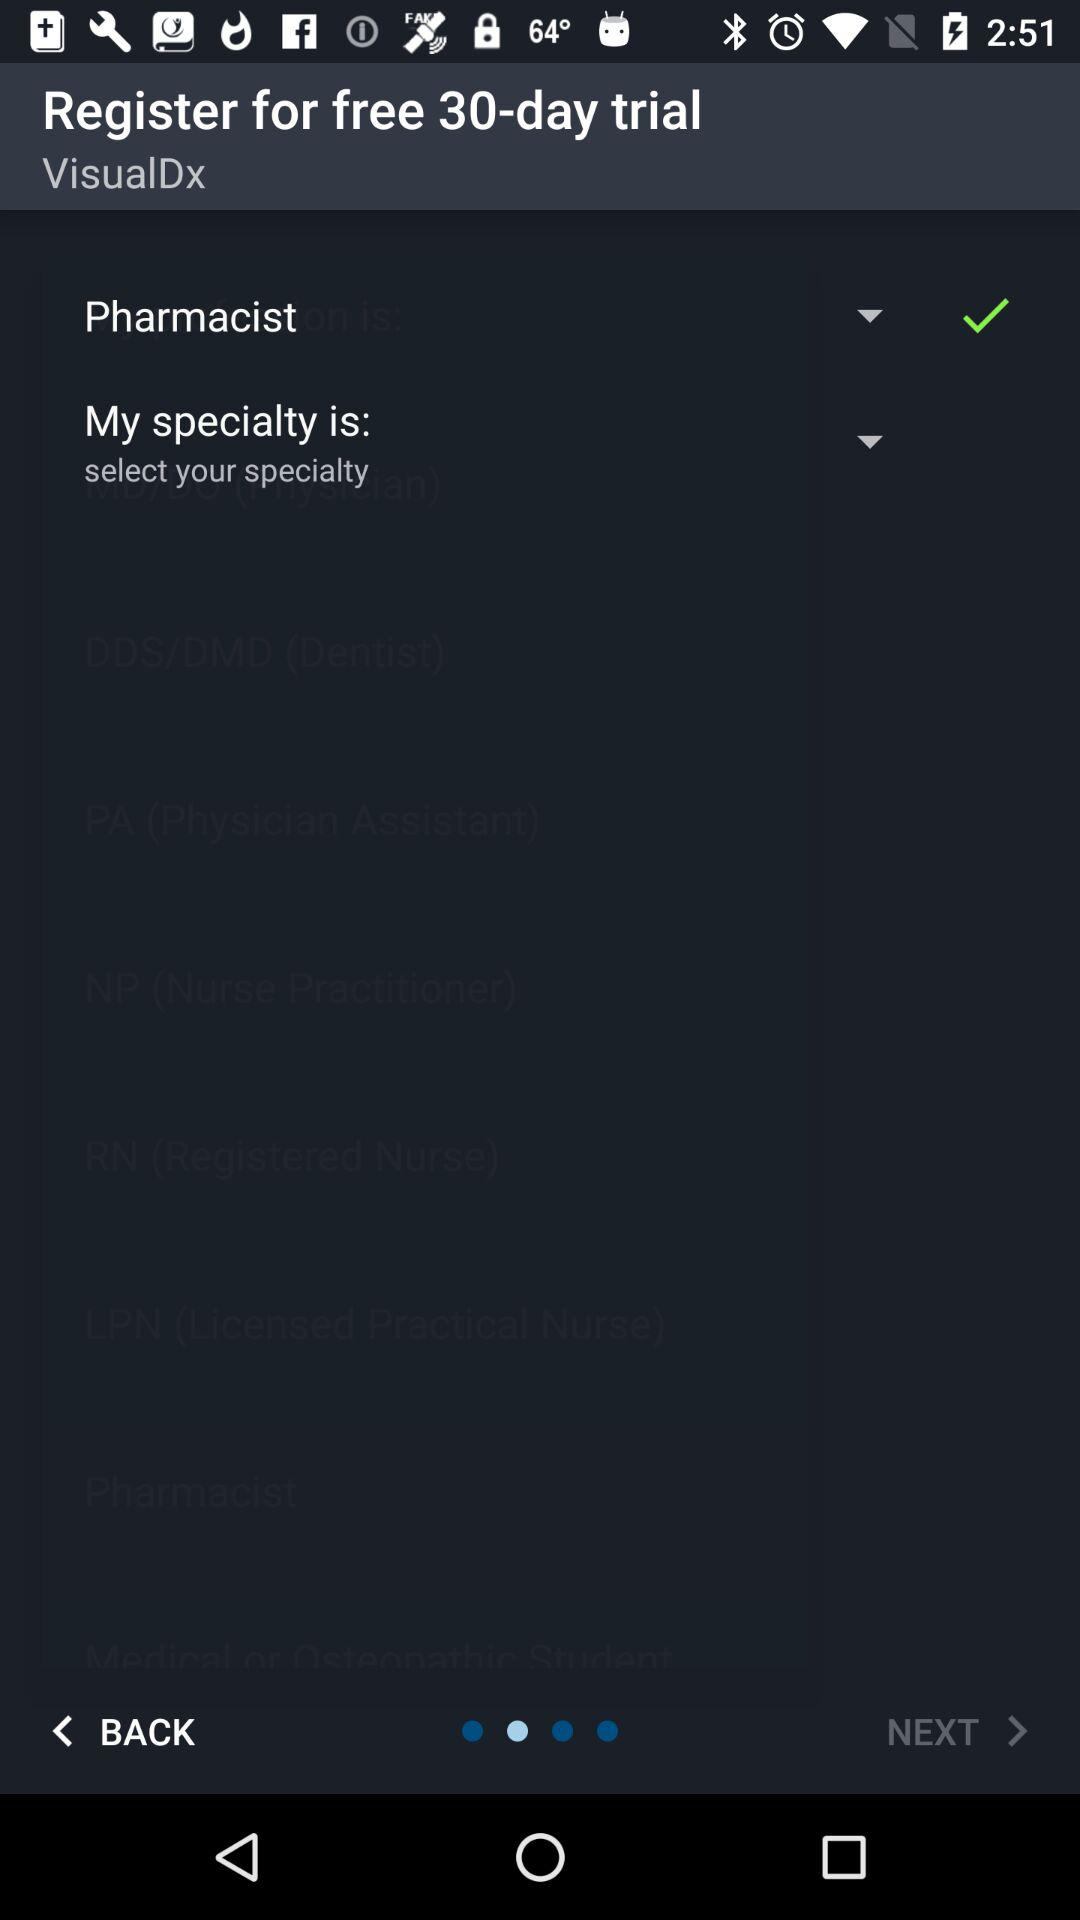For how many days is there a free trial? The free trial is for 30 days. 